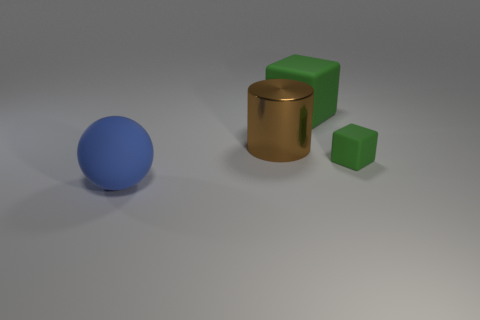What can you infer about the texture of the objects? The objects in the image exhibit a matte texture with no highlights that would signify a glossy finish. The soft shadows and even color distribution suggest a surface that diffuses light rather than reflecting it sharply. 